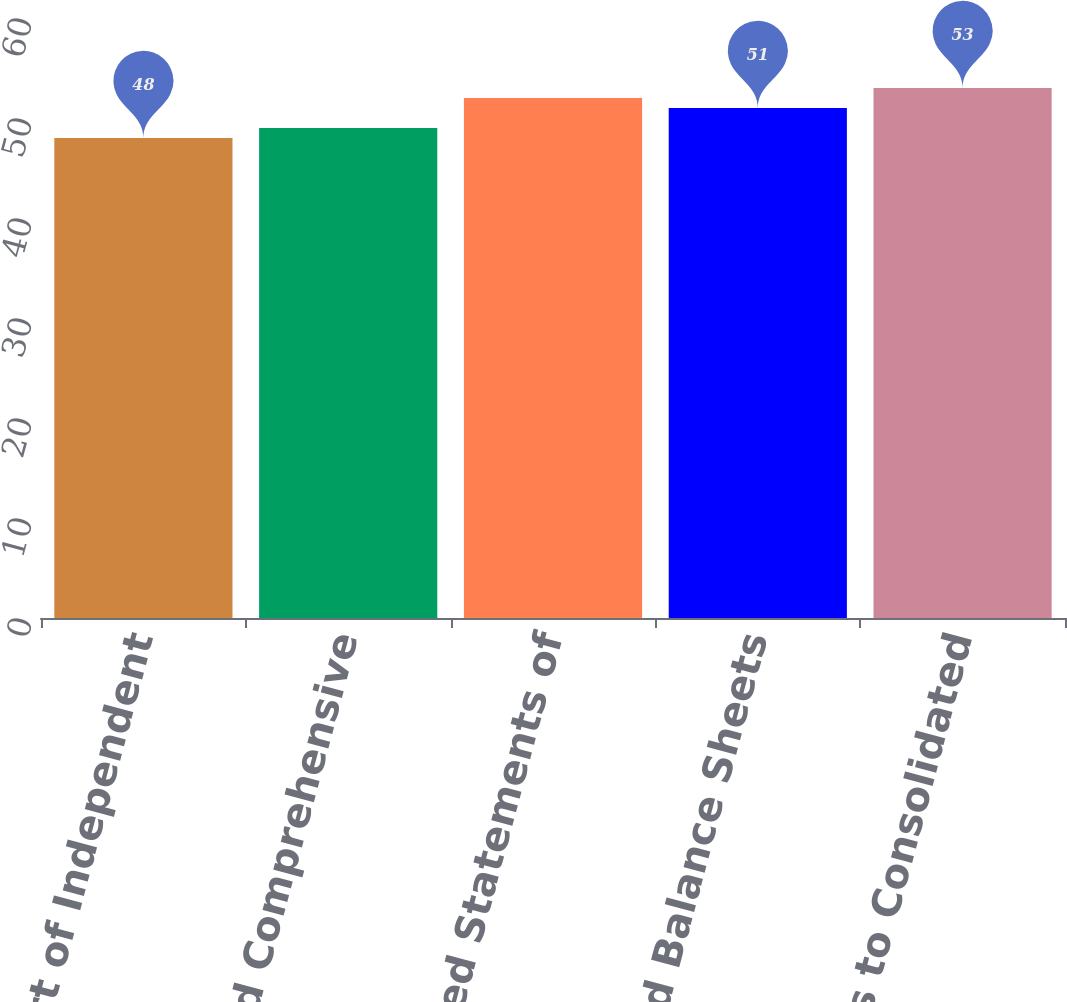Convert chart to OTSL. <chart><loc_0><loc_0><loc_500><loc_500><bar_chart><fcel>Report of Independent<fcel>Consolidated Comprehensive<fcel>Consolidated Statements of<fcel>Consolidated Balance Sheets<fcel>Notes to Consolidated<nl><fcel>48<fcel>49<fcel>52<fcel>51<fcel>53<nl></chart> 